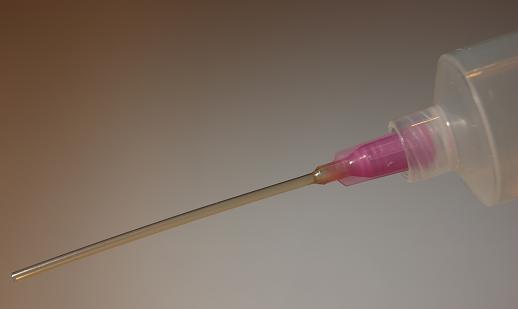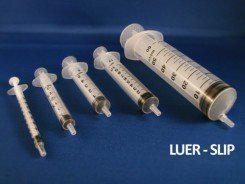The first image is the image on the left, the second image is the image on the right. For the images displayed, is the sentence "At least one image includes an all-metal syringe displayed on a red surface." factually correct? Answer yes or no. No. The first image is the image on the left, the second image is the image on the right. For the images displayed, is the sentence "At least one syringe in the image on the left has a pink tip." factually correct? Answer yes or no. Yes. 